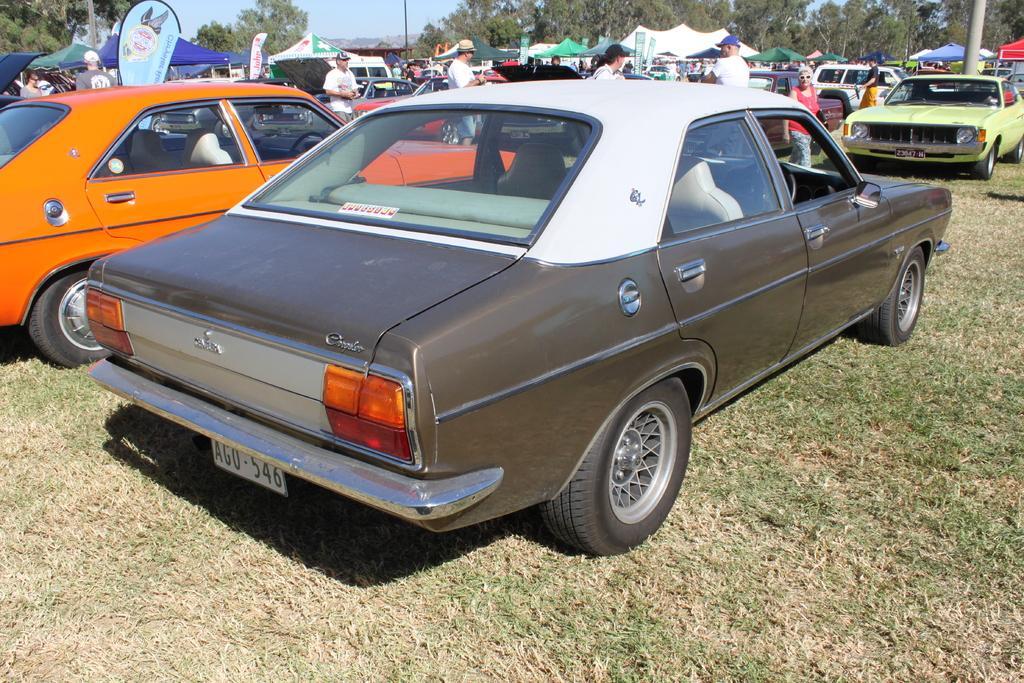Please provide a concise description of this image. In this picture we can observe a car parked on the ground which is in brown and white color. Beside this car there is an orange color car. We can observe some people standing here, wearing white color T shirts. Some of them were wearing caps on their heads. We can observe white and blue color tents. There are some cars parked on the ground. On the right side there is a pole. In the background there are trees and a sky. 